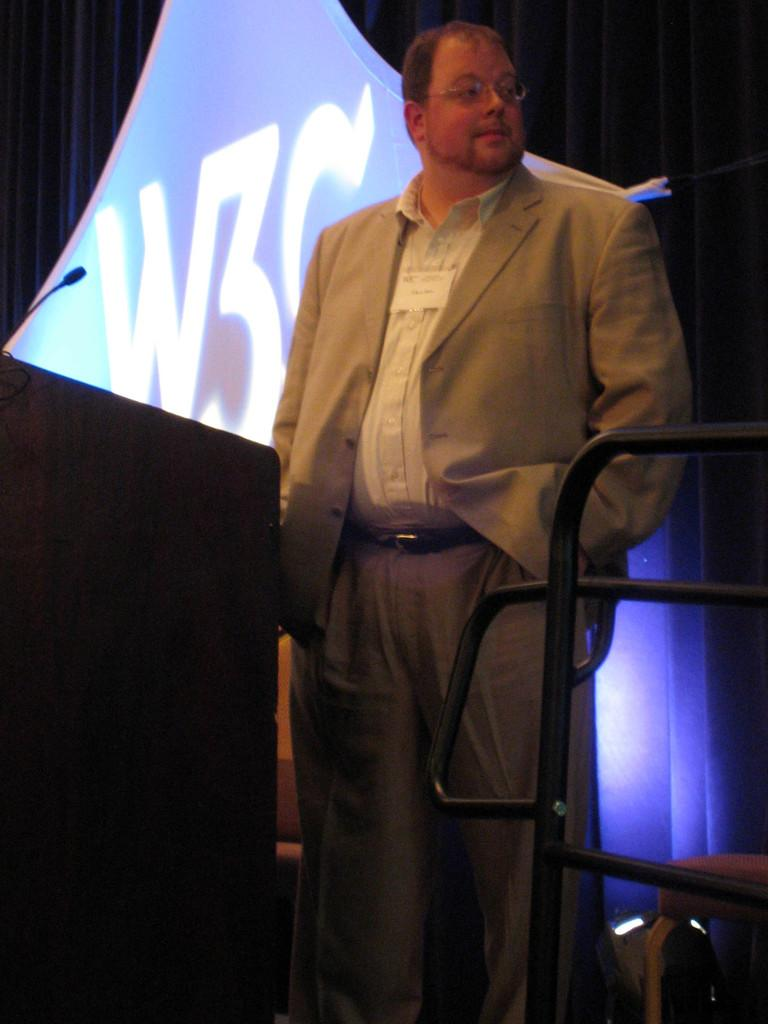What is the main subject of the image? There is a person in the image. What is the person doing in the image? The person is standing. What type of truck can be heard in the background of the image? There is no truck or any sound mentioned in the image, so it cannot be determined from the image. 